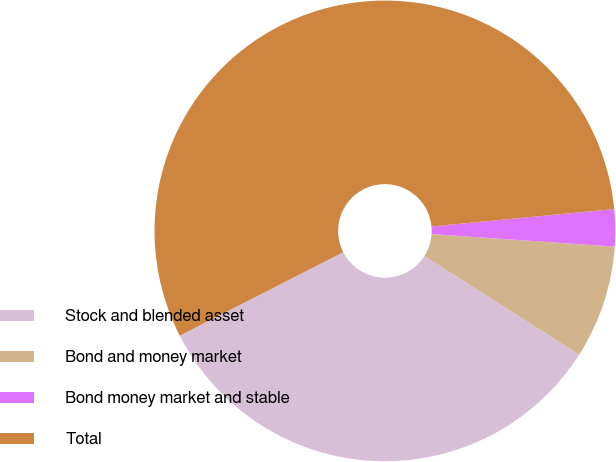Convert chart to OTSL. <chart><loc_0><loc_0><loc_500><loc_500><pie_chart><fcel>Stock and blended asset<fcel>Bond and money market<fcel>Bond money market and stable<fcel>Total<nl><fcel>33.46%<fcel>7.94%<fcel>2.6%<fcel>56.0%<nl></chart> 